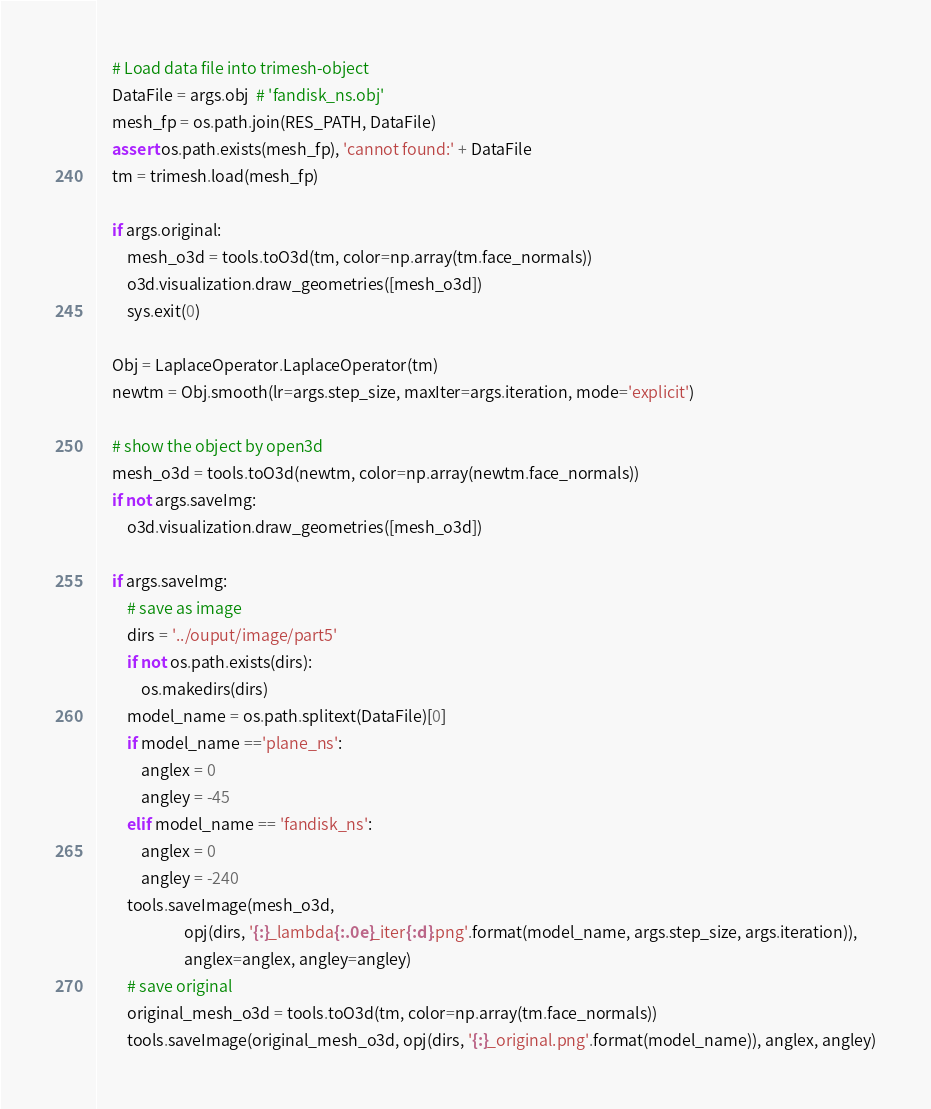Convert code to text. <code><loc_0><loc_0><loc_500><loc_500><_Python_>    # Load data file into trimesh-object
    DataFile = args.obj  # 'fandisk_ns.obj'
    mesh_fp = os.path.join(RES_PATH, DataFile)
    assert os.path.exists(mesh_fp), 'cannot found:' + DataFile
    tm = trimesh.load(mesh_fp)

    if args.original:
        mesh_o3d = tools.toO3d(tm, color=np.array(tm.face_normals))
        o3d.visualization.draw_geometries([mesh_o3d])
        sys.exit(0)

    Obj = LaplaceOperator.LaplaceOperator(tm)
    newtm = Obj.smooth(lr=args.step_size, maxIter=args.iteration, mode='explicit')

    # show the object by open3d
    mesh_o3d = tools.toO3d(newtm, color=np.array(newtm.face_normals))
    if not args.saveImg:
        o3d.visualization.draw_geometries([mesh_o3d])

    if args.saveImg:
        # save as image
        dirs = '../ouput/image/part5'
        if not os.path.exists(dirs):
            os.makedirs(dirs)
        model_name = os.path.splitext(DataFile)[0]
        if model_name =='plane_ns':
            anglex = 0
            angley = -45
        elif model_name == 'fandisk_ns':
            anglex = 0
            angley = -240
        tools.saveImage(mesh_o3d,
                        opj(dirs, '{:}_lambda{:.0e}_iter{:d}.png'.format(model_name, args.step_size, args.iteration)),
                        anglex=anglex, angley=angley)
        # save original
        original_mesh_o3d = tools.toO3d(tm, color=np.array(tm.face_normals))
        tools.saveImage(original_mesh_o3d, opj(dirs, '{:}_original.png'.format(model_name)), anglex, angley)
</code> 